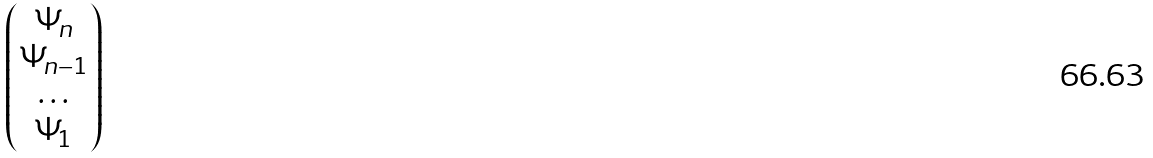<formula> <loc_0><loc_0><loc_500><loc_500>\begin{pmatrix} \Psi _ { n } \\ \Psi _ { n - 1 } \\ \hdots \\ \Psi _ { 1 } \end{pmatrix}</formula> 